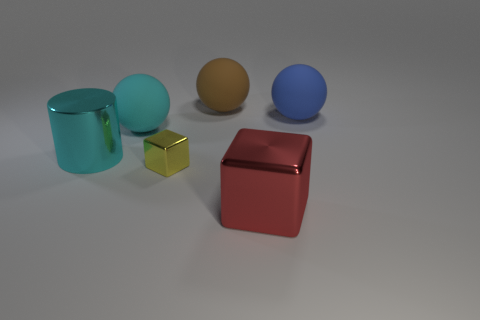There is a large block that is the same material as the cylinder; what is its color?
Your answer should be compact. Red. What number of rubber things are either cyan cylinders or balls?
Offer a terse response. 3. Is the material of the brown thing the same as the big blue ball?
Your answer should be very brief. Yes. What is the shape of the thing that is right of the big red shiny object?
Keep it short and to the point. Sphere. There is a block that is to the left of the red metal thing; are there any small yellow shiny cubes that are behind it?
Make the answer very short. No. Is there a shiny cube of the same size as the brown ball?
Keep it short and to the point. Yes. Is the color of the cube to the left of the large brown rubber thing the same as the big cube?
Provide a succinct answer. No. How big is the cyan metal thing?
Your response must be concise. Large. There is a cyan object that is in front of the cyan object that is behind the large cylinder; how big is it?
Offer a very short reply. Large. How many rubber objects are the same color as the big metal block?
Make the answer very short. 0. 